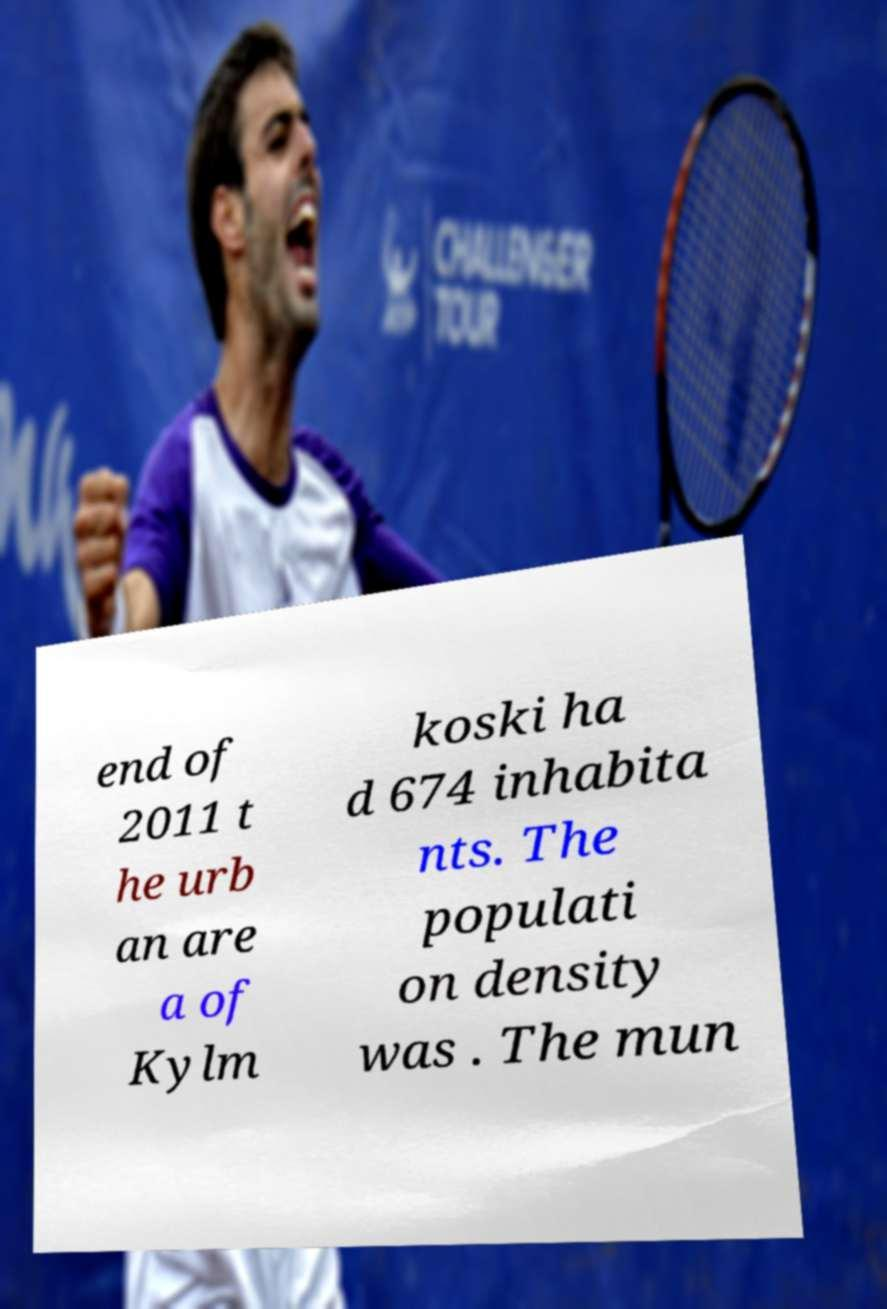Could you assist in decoding the text presented in this image and type it out clearly? end of 2011 t he urb an are a of Kylm koski ha d 674 inhabita nts. The populati on density was . The mun 